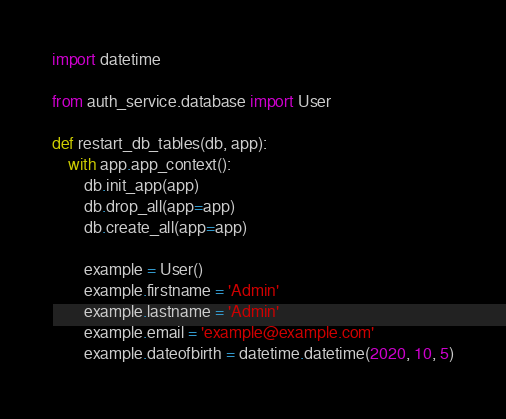<code> <loc_0><loc_0><loc_500><loc_500><_Python_>import datetime

from auth_service.database import User

def restart_db_tables(db, app):
    with app.app_context():
        db.init_app(app)
        db.drop_all(app=app)
        db.create_all(app=app)

        example = User()
        example.firstname = 'Admin'
        example.lastname = 'Admin'
        example.email = 'example@example.com'
        example.dateofbirth = datetime.datetime(2020, 10, 5)</code> 